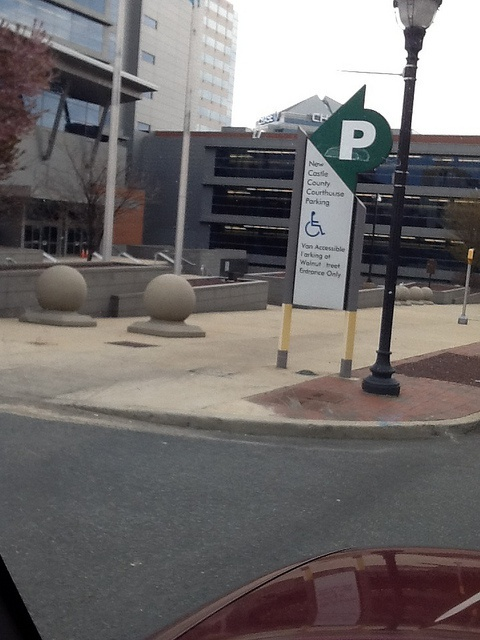Describe the objects in this image and their specific colors. I can see a car in gray, maroon, black, and brown tones in this image. 